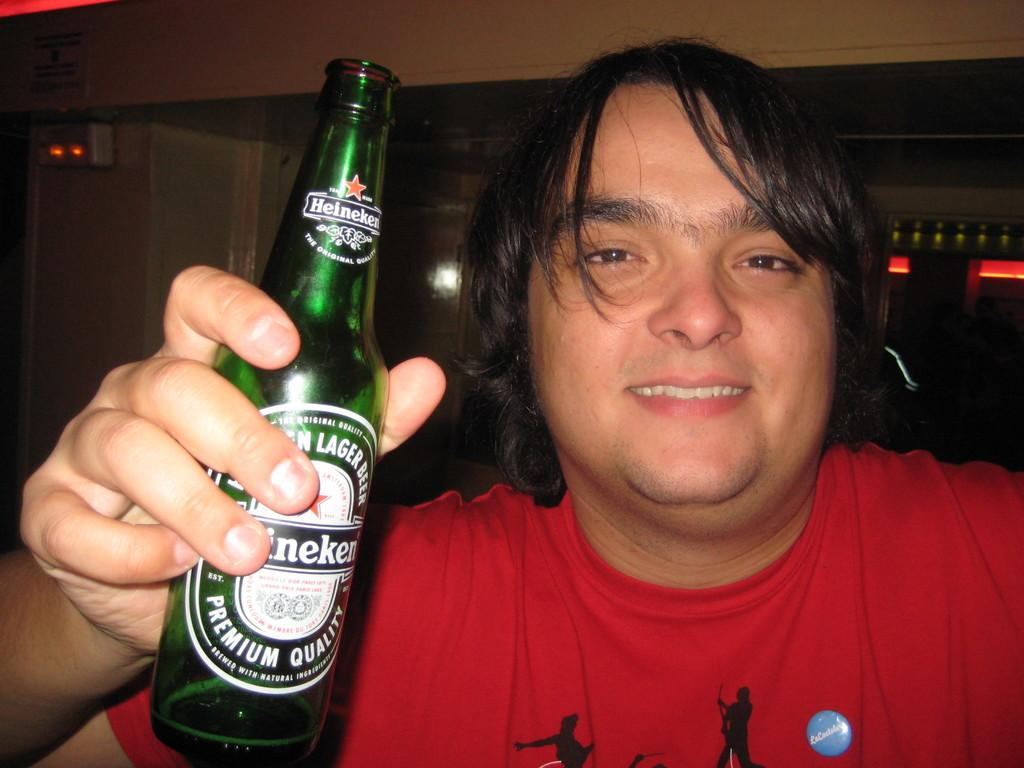What is the main subject of the image? There is a person in the image. What is the person wearing? The person is wearing a red t-shirt. What object is the person holding? The person is holding a green bottle. What can be seen in the background of the image? There are bottles and a white wall in the background of the image. What type of jewel is the person wearing in the image? There is no mention of a jewel in the image; the person is only described as wearing a red t-shirt. 